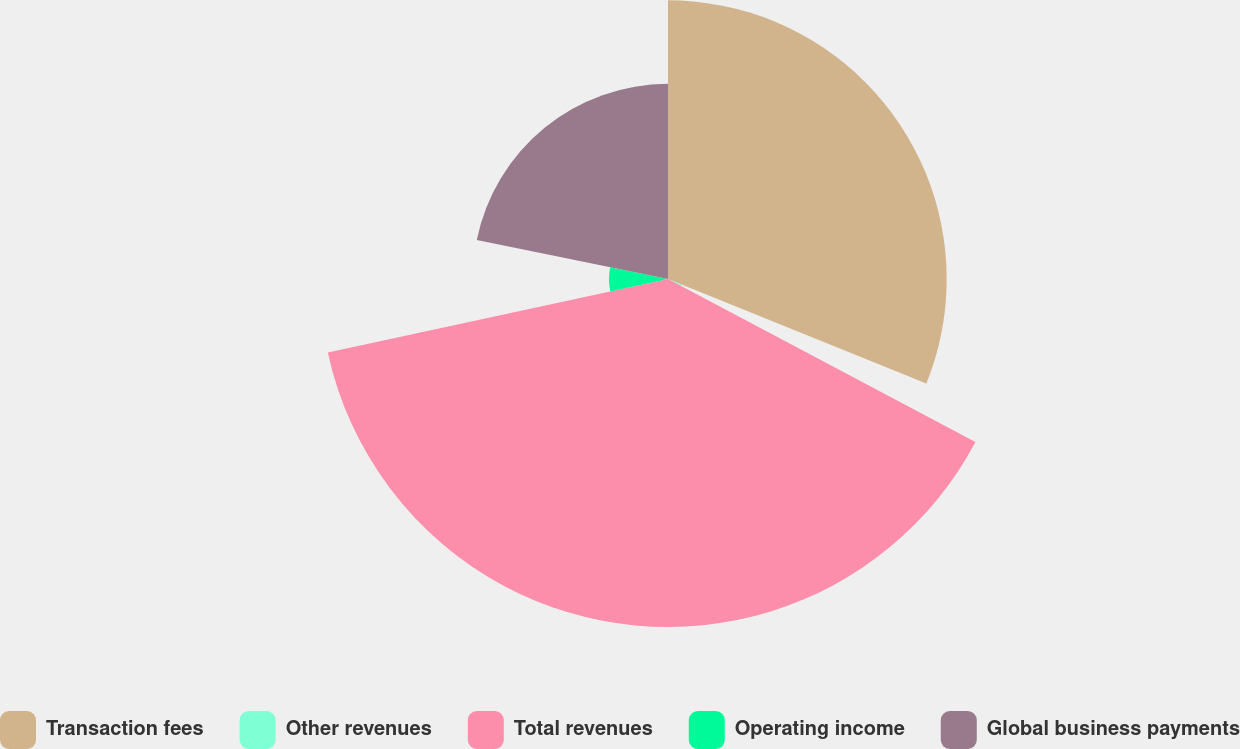Convert chart to OTSL. <chart><loc_0><loc_0><loc_500><loc_500><pie_chart><fcel>Transaction fees<fcel>Other revenues<fcel>Total revenues<fcel>Operating income<fcel>Global business payments<nl><fcel>31.11%<fcel>1.65%<fcel>38.85%<fcel>6.59%<fcel>21.79%<nl></chart> 